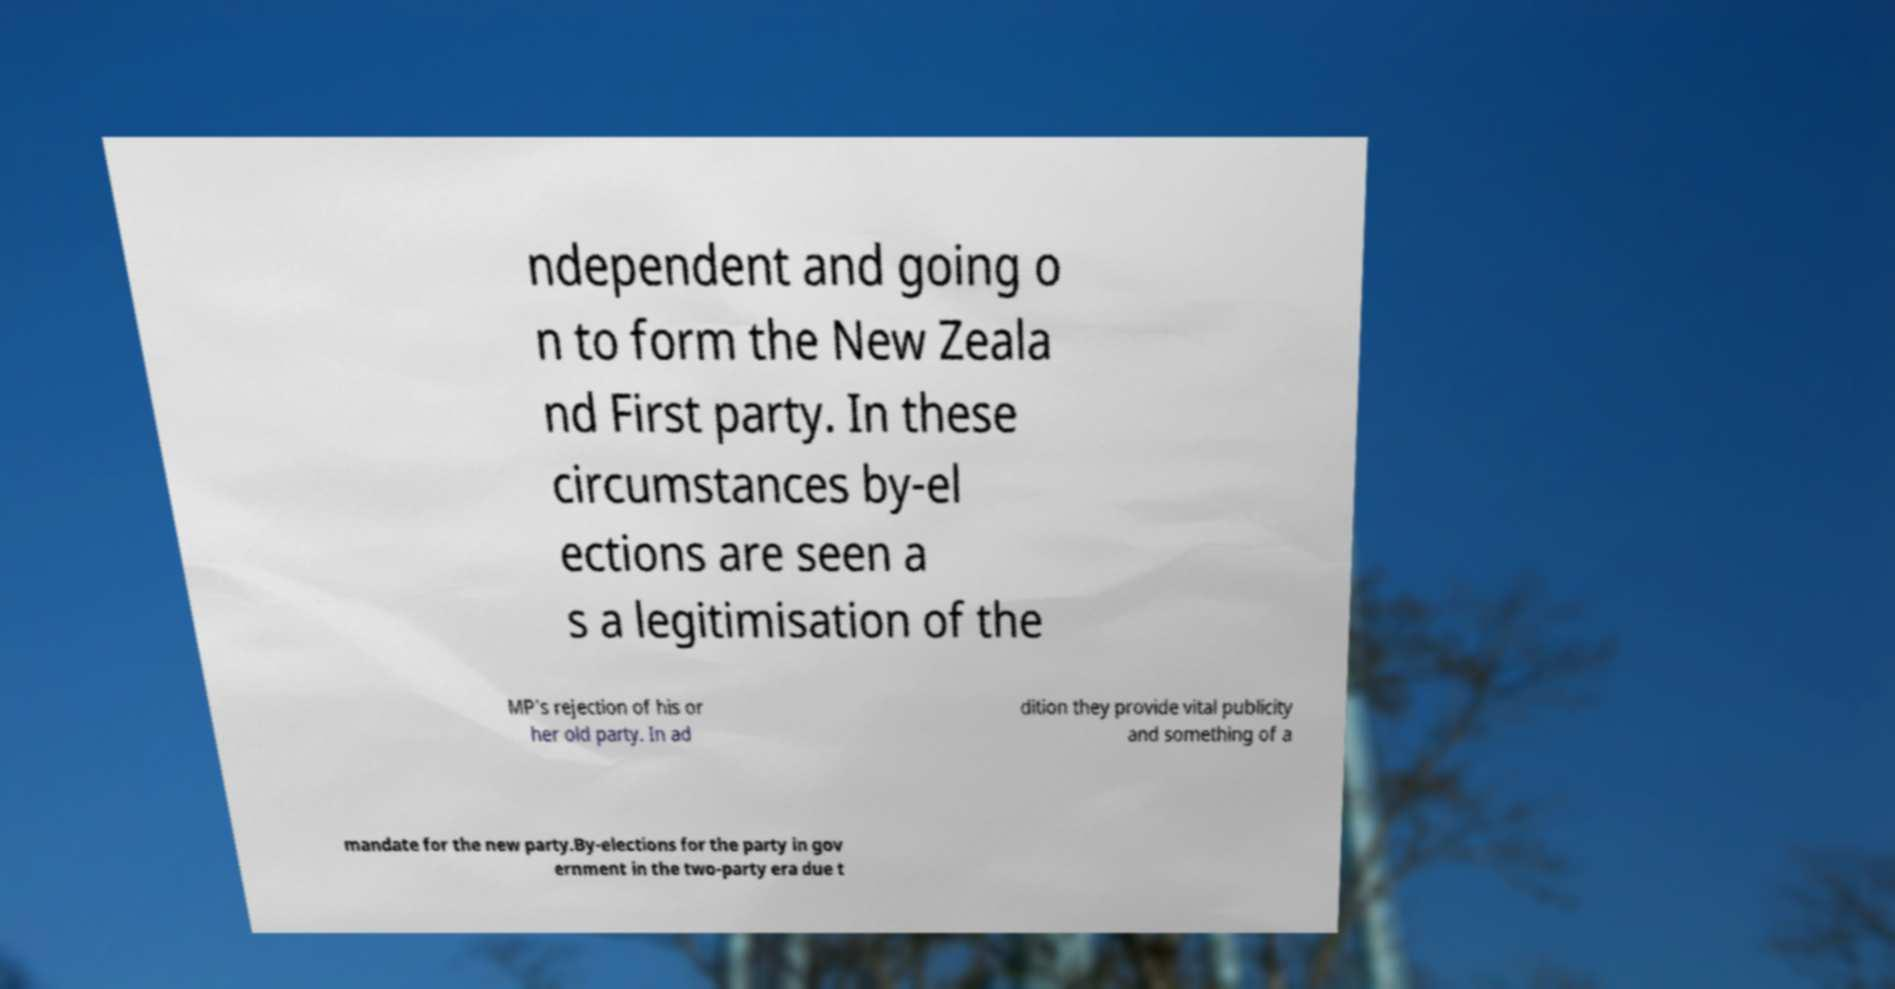There's text embedded in this image that I need extracted. Can you transcribe it verbatim? ndependent and going o n to form the New Zeala nd First party. In these circumstances by-el ections are seen a s a legitimisation of the MP's rejection of his or her old party. In ad dition they provide vital publicity and something of a mandate for the new party.By-elections for the party in gov ernment in the two-party era due t 